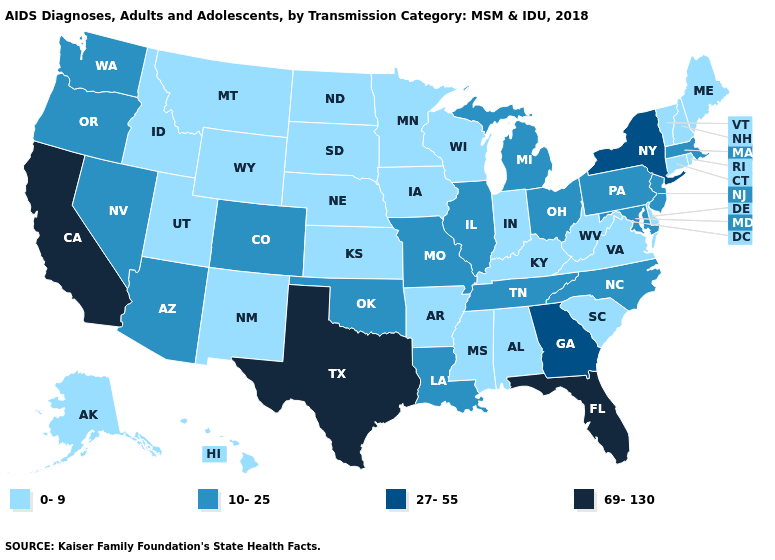Which states have the lowest value in the USA?
Quick response, please. Alabama, Alaska, Arkansas, Connecticut, Delaware, Hawaii, Idaho, Indiana, Iowa, Kansas, Kentucky, Maine, Minnesota, Mississippi, Montana, Nebraska, New Hampshire, New Mexico, North Dakota, Rhode Island, South Carolina, South Dakota, Utah, Vermont, Virginia, West Virginia, Wisconsin, Wyoming. Among the states that border Vermont , does Massachusetts have the highest value?
Write a very short answer. No. What is the lowest value in the USA?
Quick response, please. 0-9. Name the states that have a value in the range 0-9?
Answer briefly. Alabama, Alaska, Arkansas, Connecticut, Delaware, Hawaii, Idaho, Indiana, Iowa, Kansas, Kentucky, Maine, Minnesota, Mississippi, Montana, Nebraska, New Hampshire, New Mexico, North Dakota, Rhode Island, South Carolina, South Dakota, Utah, Vermont, Virginia, West Virginia, Wisconsin, Wyoming. What is the highest value in the West ?
Write a very short answer. 69-130. Name the states that have a value in the range 10-25?
Concise answer only. Arizona, Colorado, Illinois, Louisiana, Maryland, Massachusetts, Michigan, Missouri, Nevada, New Jersey, North Carolina, Ohio, Oklahoma, Oregon, Pennsylvania, Tennessee, Washington. Does North Dakota have the highest value in the USA?
Give a very brief answer. No. Name the states that have a value in the range 0-9?
Concise answer only. Alabama, Alaska, Arkansas, Connecticut, Delaware, Hawaii, Idaho, Indiana, Iowa, Kansas, Kentucky, Maine, Minnesota, Mississippi, Montana, Nebraska, New Hampshire, New Mexico, North Dakota, Rhode Island, South Carolina, South Dakota, Utah, Vermont, Virginia, West Virginia, Wisconsin, Wyoming. Does Texas have a lower value than North Carolina?
Write a very short answer. No. Does the map have missing data?
Quick response, please. No. What is the value of Minnesota?
Be succinct. 0-9. What is the value of New Jersey?
Be succinct. 10-25. Which states have the lowest value in the USA?
Concise answer only. Alabama, Alaska, Arkansas, Connecticut, Delaware, Hawaii, Idaho, Indiana, Iowa, Kansas, Kentucky, Maine, Minnesota, Mississippi, Montana, Nebraska, New Hampshire, New Mexico, North Dakota, Rhode Island, South Carolina, South Dakota, Utah, Vermont, Virginia, West Virginia, Wisconsin, Wyoming. What is the value of Massachusetts?
Give a very brief answer. 10-25. What is the lowest value in the Northeast?
Give a very brief answer. 0-9. 